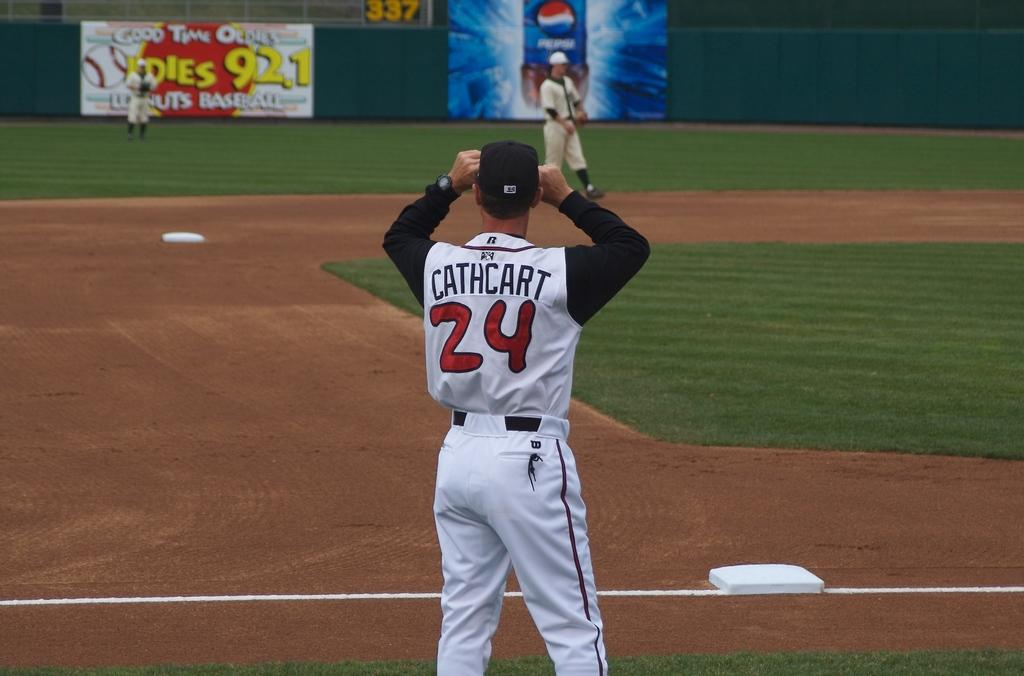<image>
Describe the image concisely. Number 24 Cathcart waiting for a ball at a basball game. 